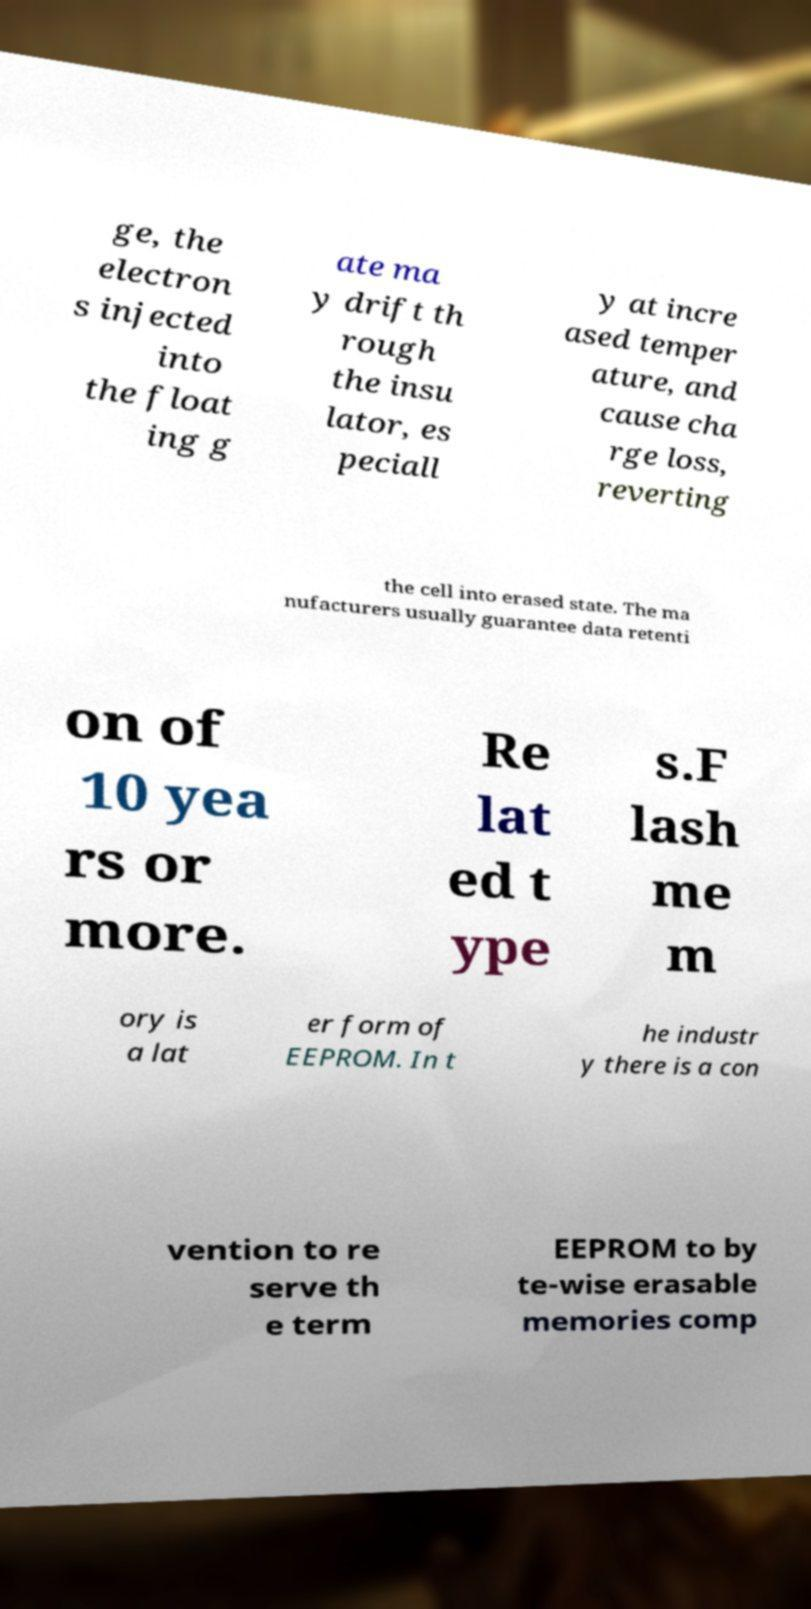Could you extract and type out the text from this image? ge, the electron s injected into the float ing g ate ma y drift th rough the insu lator, es peciall y at incre ased temper ature, and cause cha rge loss, reverting the cell into erased state. The ma nufacturers usually guarantee data retenti on of 10 yea rs or more. Re lat ed t ype s.F lash me m ory is a lat er form of EEPROM. In t he industr y there is a con vention to re serve th e term EEPROM to by te-wise erasable memories comp 